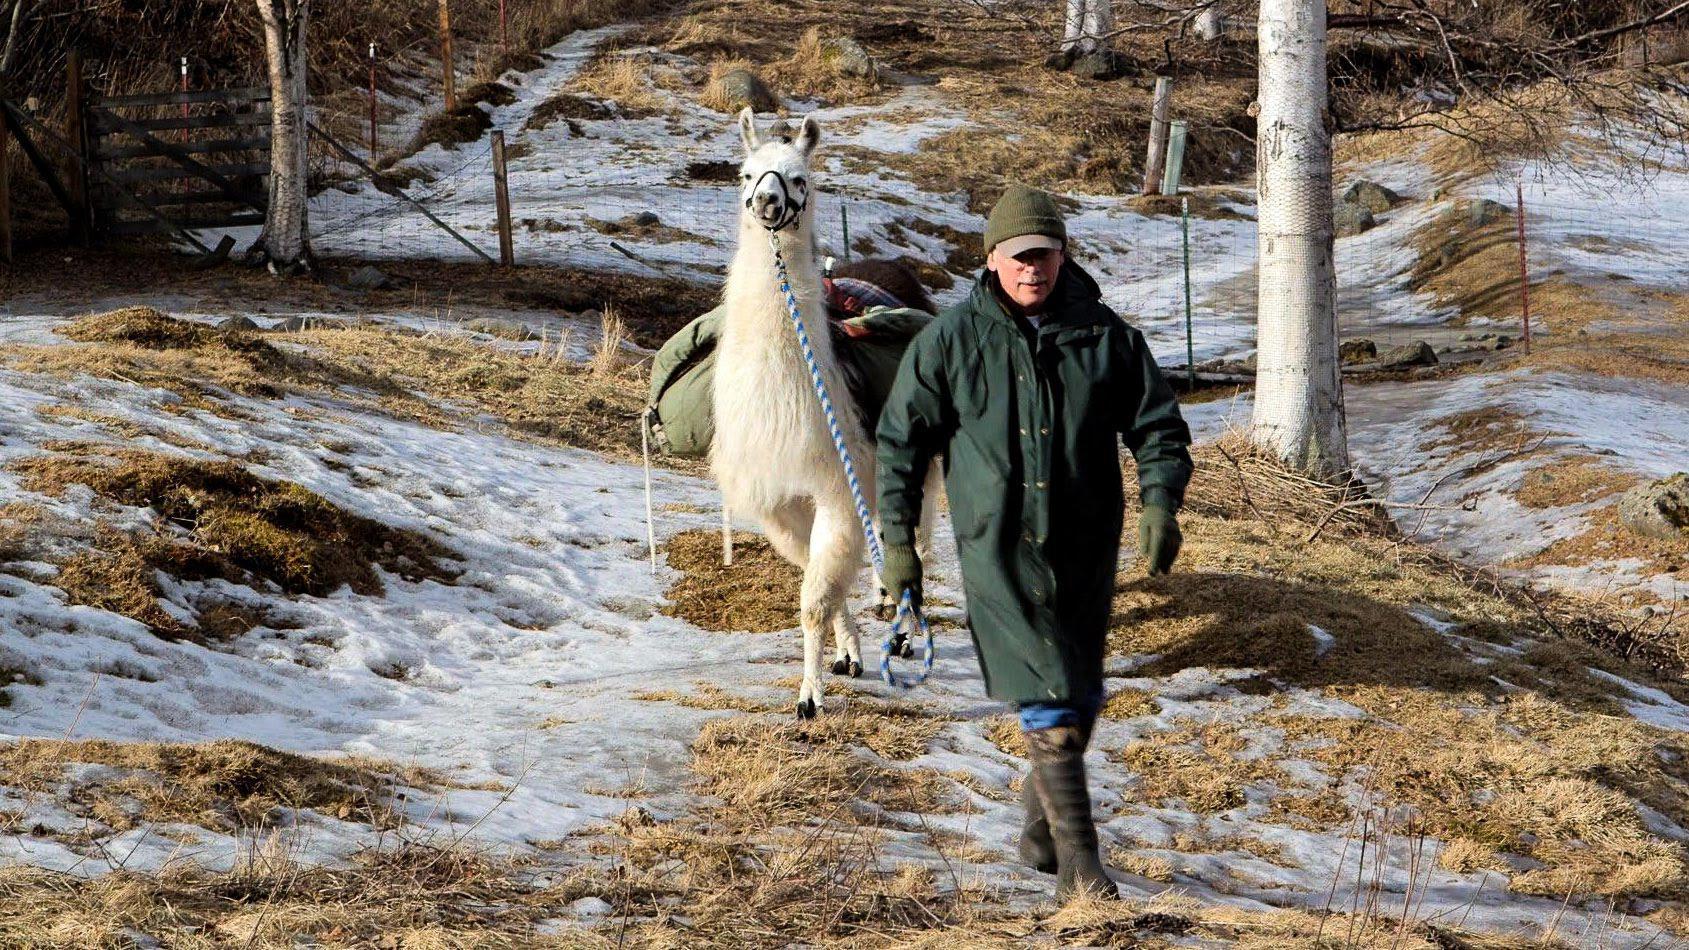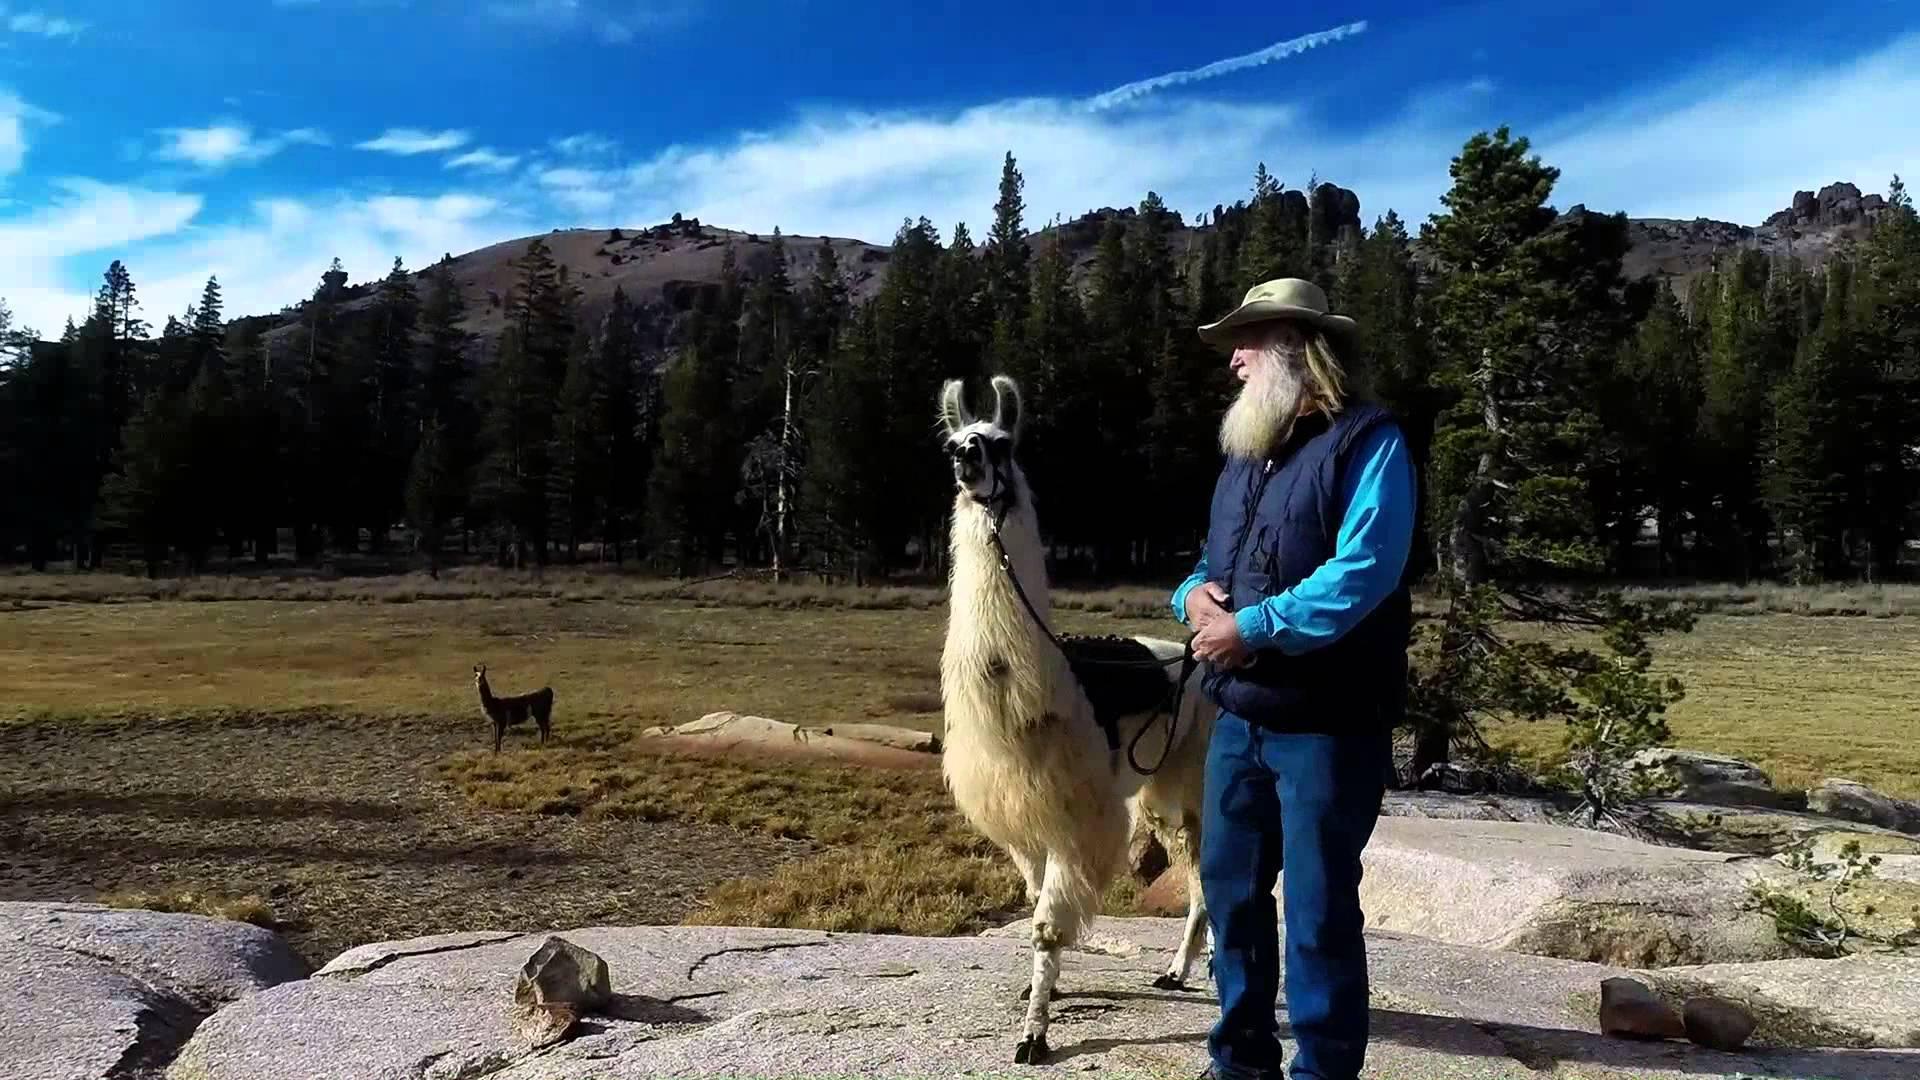The first image is the image on the left, the second image is the image on the right. Given the left and right images, does the statement "The left image contains a single llama and a single person." hold true? Answer yes or no. Yes. 